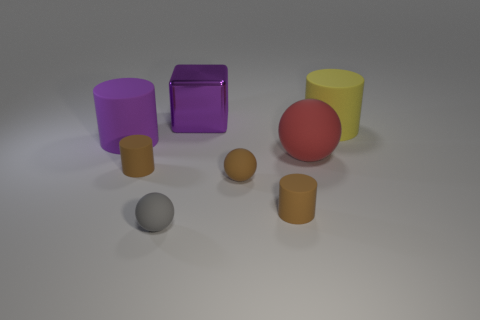Add 1 tiny green metallic blocks. How many objects exist? 9 Subtract all red spheres. How many spheres are left? 2 Subtract 1 cubes. How many cubes are left? 0 Subtract all red spheres. How many spheres are left? 2 Subtract all balls. How many objects are left? 5 Subtract all cyan cylinders. How many cyan blocks are left? 0 Subtract all purple shiny things. Subtract all blue rubber spheres. How many objects are left? 7 Add 3 brown matte things. How many brown matte things are left? 6 Add 7 tiny blue cylinders. How many tiny blue cylinders exist? 7 Subtract 0 blue cylinders. How many objects are left? 8 